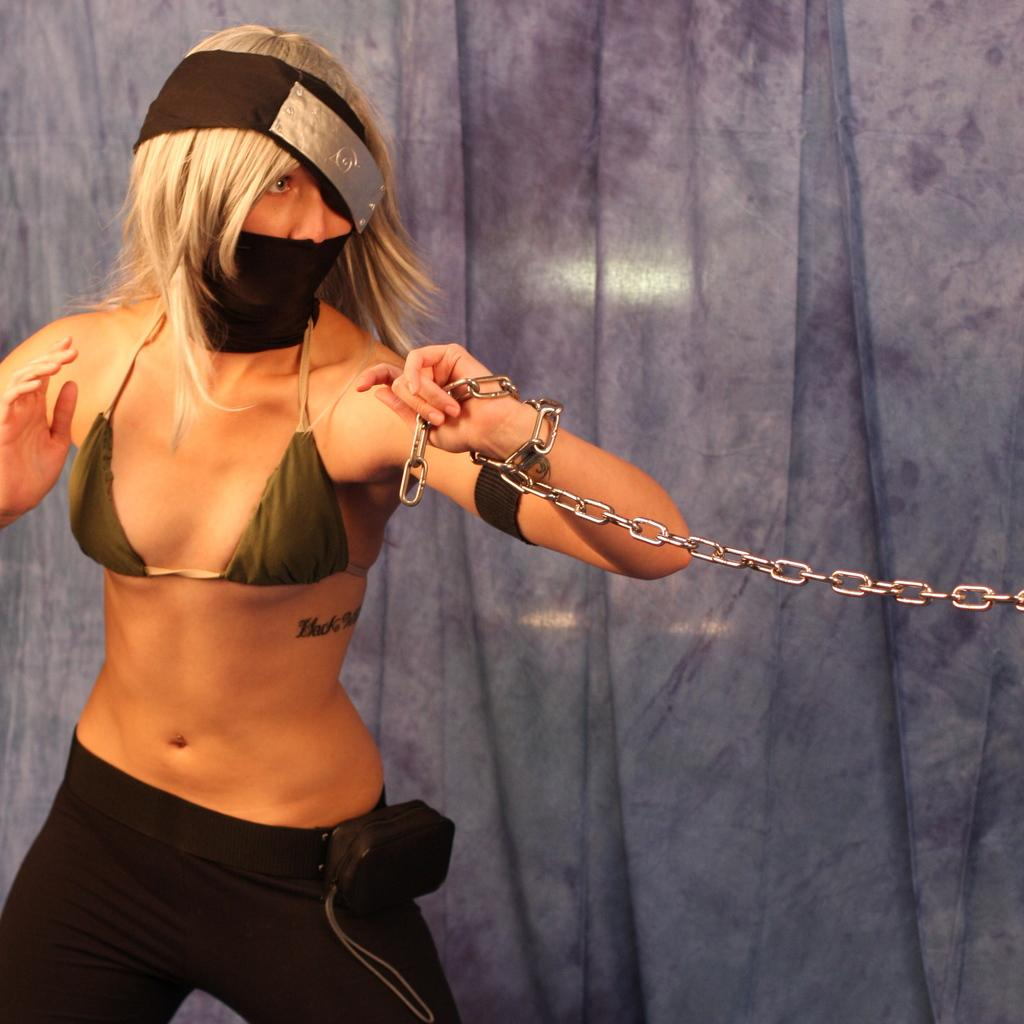What is the main subject of the image? There is a person or woman standing in the image. What is the person or woman wearing on their face? The person or woman is wearing a mask. Can you describe any other objects or features in the image? There is a metal chain visible in the image. What type of beef is being served at the event in the image? There is no event or beef present in the image; it features a person or woman wearing a mask and a metal chain. Can you tell me the name of the judge presiding over the case in the image? There is no judge or case present in the image; it features a person or woman wearing a mask and a metal chain. 